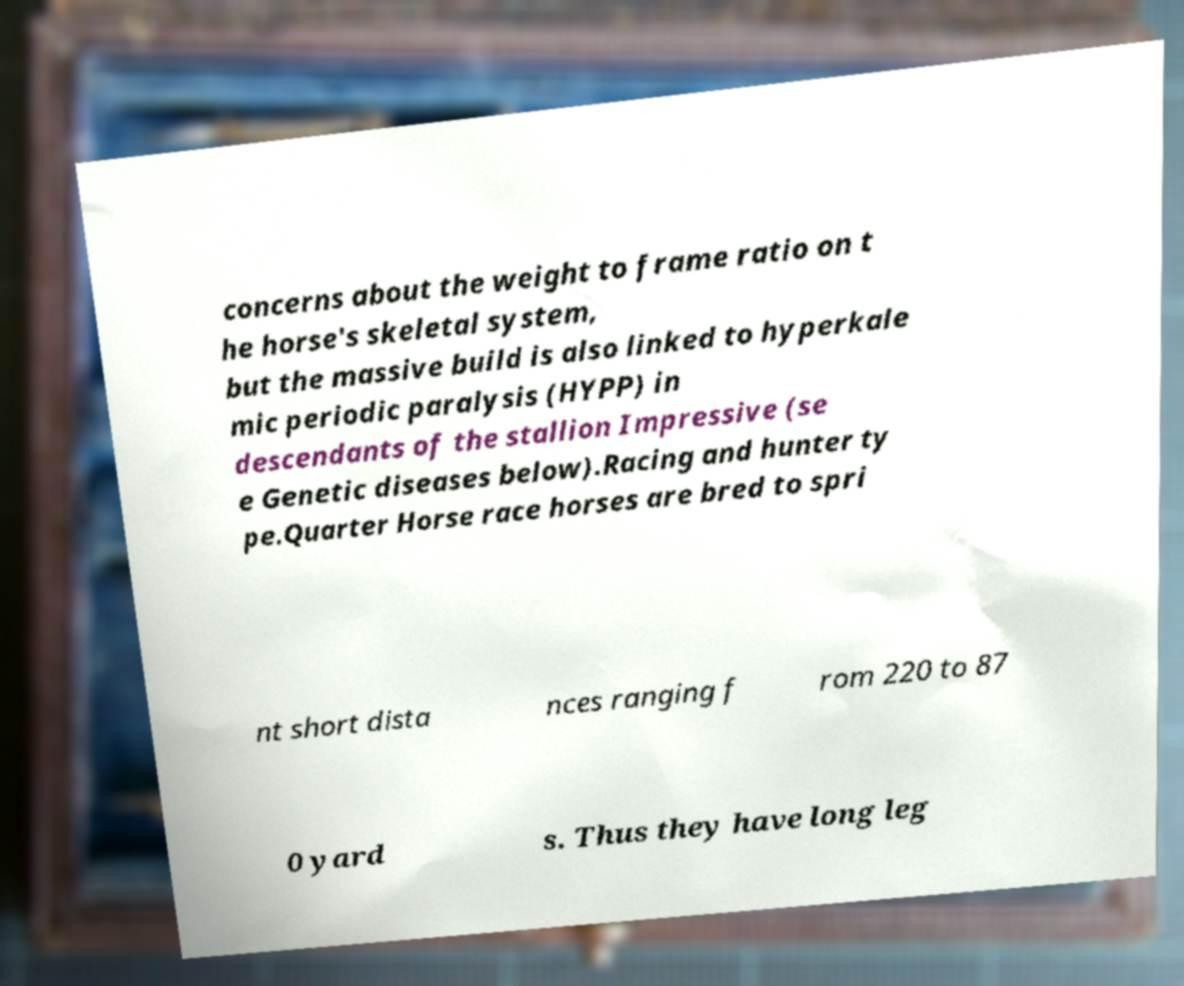I need the written content from this picture converted into text. Can you do that? concerns about the weight to frame ratio on t he horse's skeletal system, but the massive build is also linked to hyperkale mic periodic paralysis (HYPP) in descendants of the stallion Impressive (se e Genetic diseases below).Racing and hunter ty pe.Quarter Horse race horses are bred to spri nt short dista nces ranging f rom 220 to 87 0 yard s. Thus they have long leg 